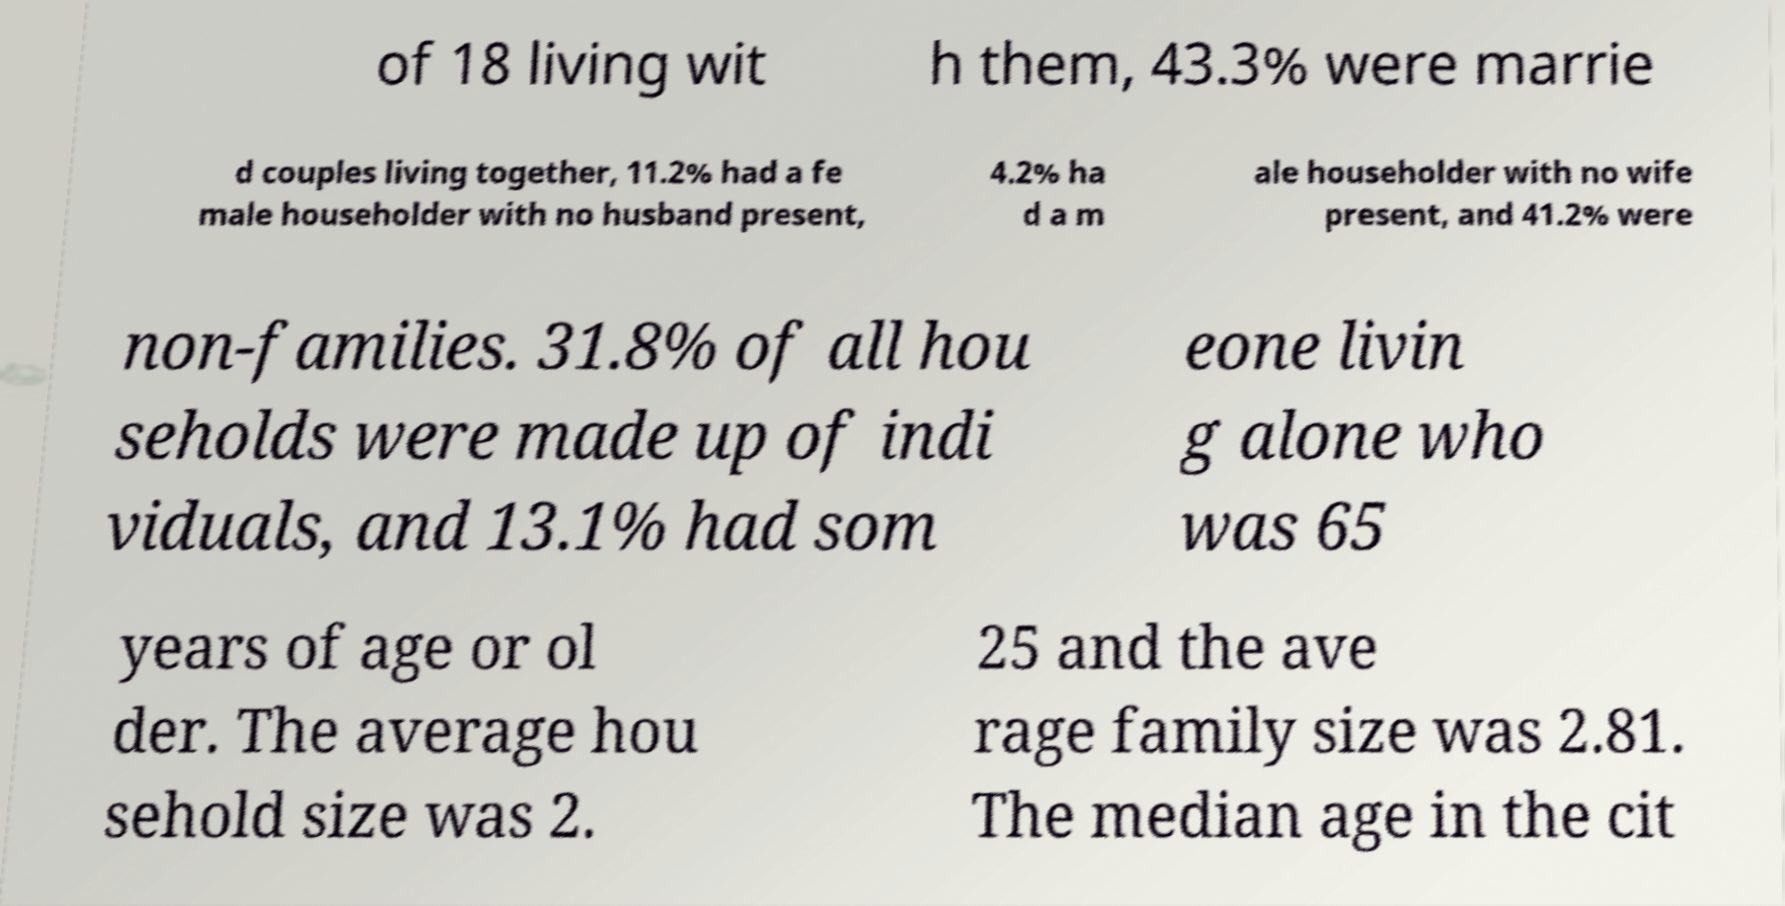For documentation purposes, I need the text within this image transcribed. Could you provide that? of 18 living wit h them, 43.3% were marrie d couples living together, 11.2% had a fe male householder with no husband present, 4.2% ha d a m ale householder with no wife present, and 41.2% were non-families. 31.8% of all hou seholds were made up of indi viduals, and 13.1% had som eone livin g alone who was 65 years of age or ol der. The average hou sehold size was 2. 25 and the ave rage family size was 2.81. The median age in the cit 